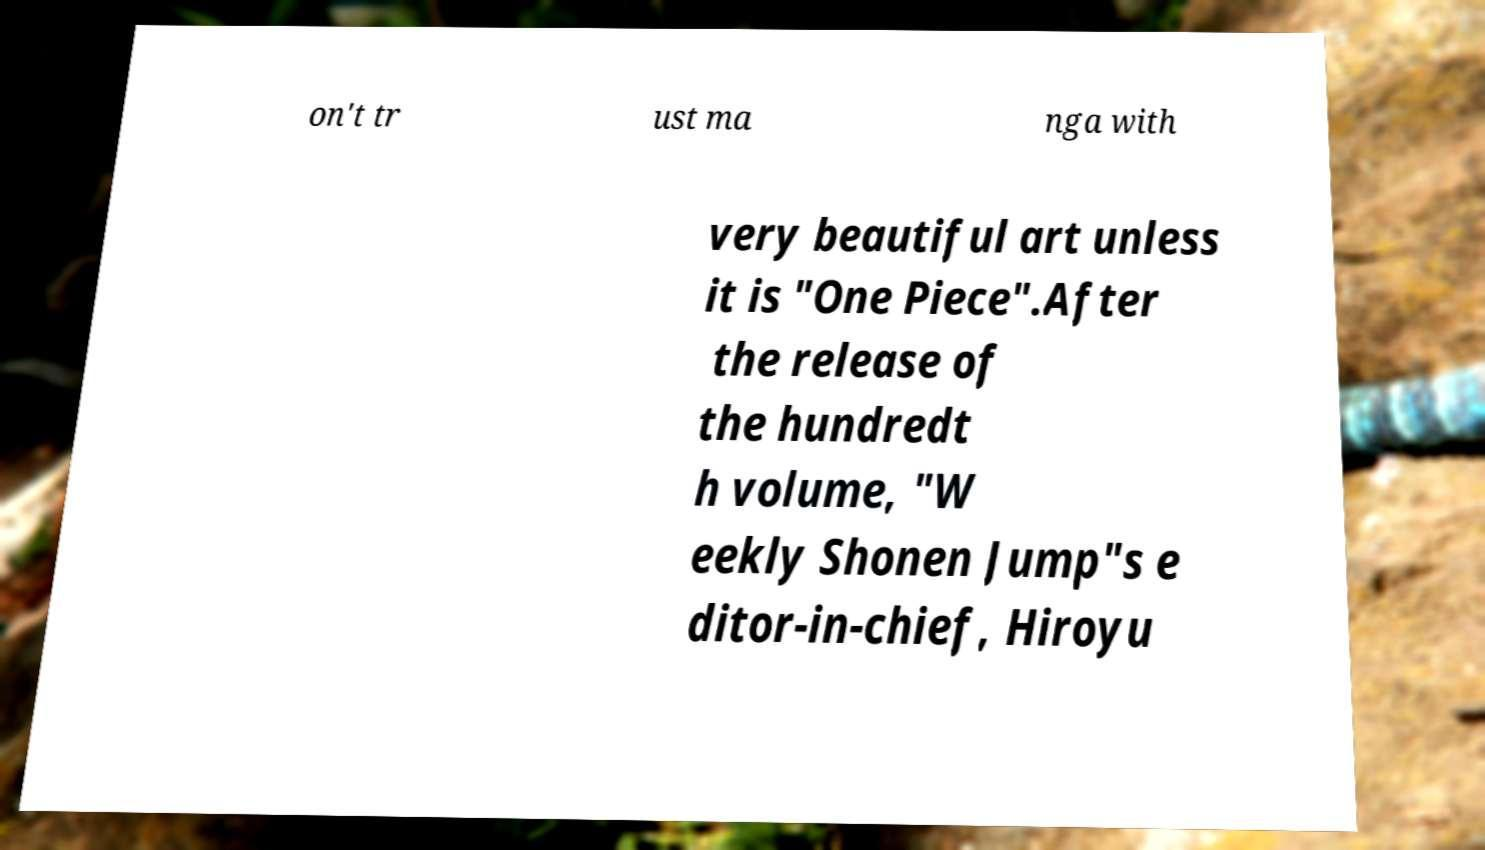Could you assist in decoding the text presented in this image and type it out clearly? on't tr ust ma nga with very beautiful art unless it is "One Piece".After the release of the hundredt h volume, "W eekly Shonen Jump"s e ditor-in-chief, Hiroyu 